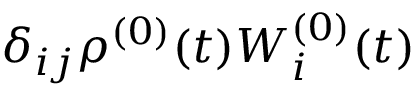Convert formula to latex. <formula><loc_0><loc_0><loc_500><loc_500>\delta _ { i j } \rho ^ { ( 0 ) } ( t ) W _ { i } ^ { ( 0 ) } ( t )</formula> 